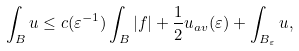Convert formula to latex. <formula><loc_0><loc_0><loc_500><loc_500>\int _ { B } u \leq c ( \varepsilon ^ { - 1 } ) \int _ { B } | f | + { \frac { 1 } { 2 } } u _ { a v } ( \varepsilon ) + \int _ { B _ { \varepsilon } } u ,</formula> 